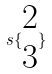Convert formula to latex. <formula><loc_0><loc_0><loc_500><loc_500>s \{ \begin{matrix} 2 \\ 3 \end{matrix} \}</formula> 